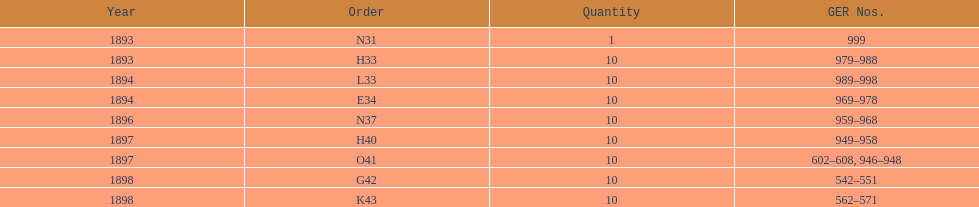At the top of the table, which sequence is placed first? N31. 